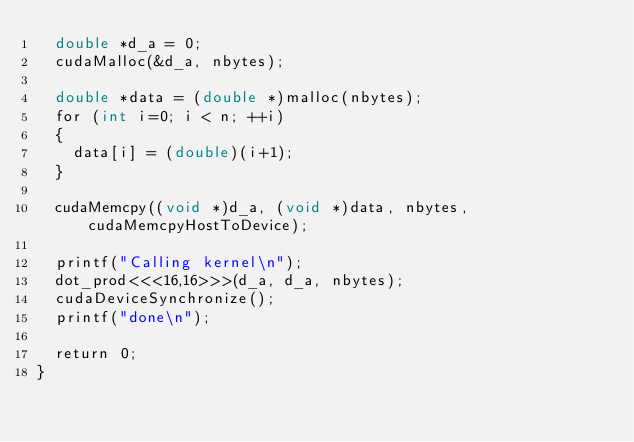<code> <loc_0><loc_0><loc_500><loc_500><_Cuda_>  double *d_a = 0;
  cudaMalloc(&d_a, nbytes);

  double *data = (double *)malloc(nbytes);
  for (int i=0; i < n; ++i)
  {
    data[i] = (double)(i+1);
  }

  cudaMemcpy((void *)d_a, (void *)data, nbytes, cudaMemcpyHostToDevice);

  printf("Calling kernel\n");
  dot_prod<<<16,16>>>(d_a, d_a, nbytes);
  cudaDeviceSynchronize();
  printf("done\n");

  return 0;
}
</code> 